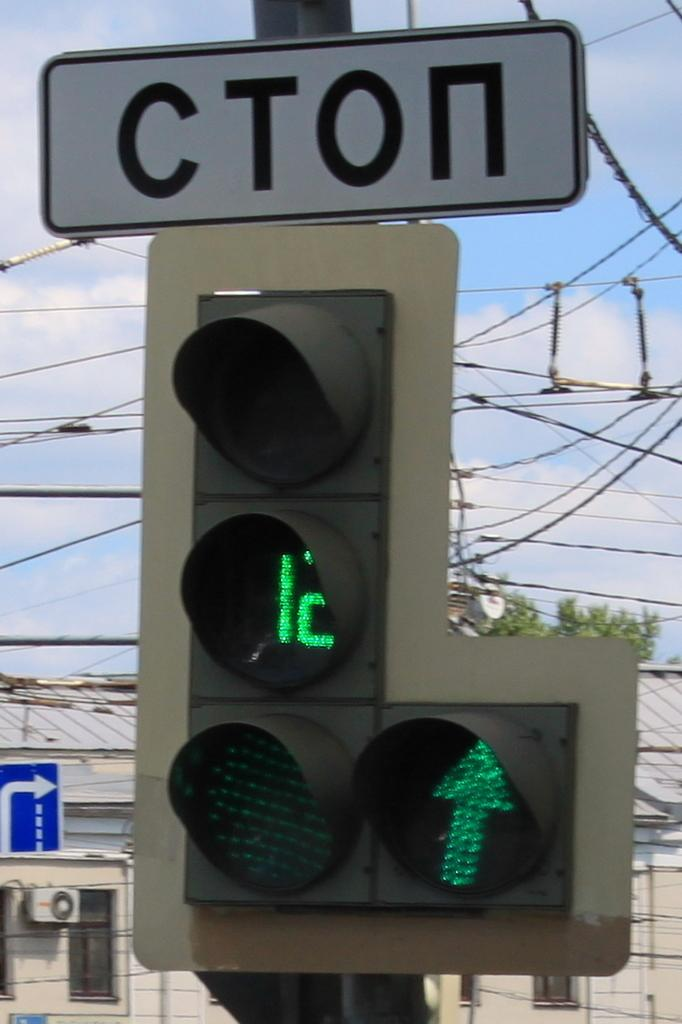<image>
Present a compact description of the photo's key features. some traffic lights with the word CTON on the top 